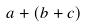<formula> <loc_0><loc_0><loc_500><loc_500>a + ( b + c )</formula> 